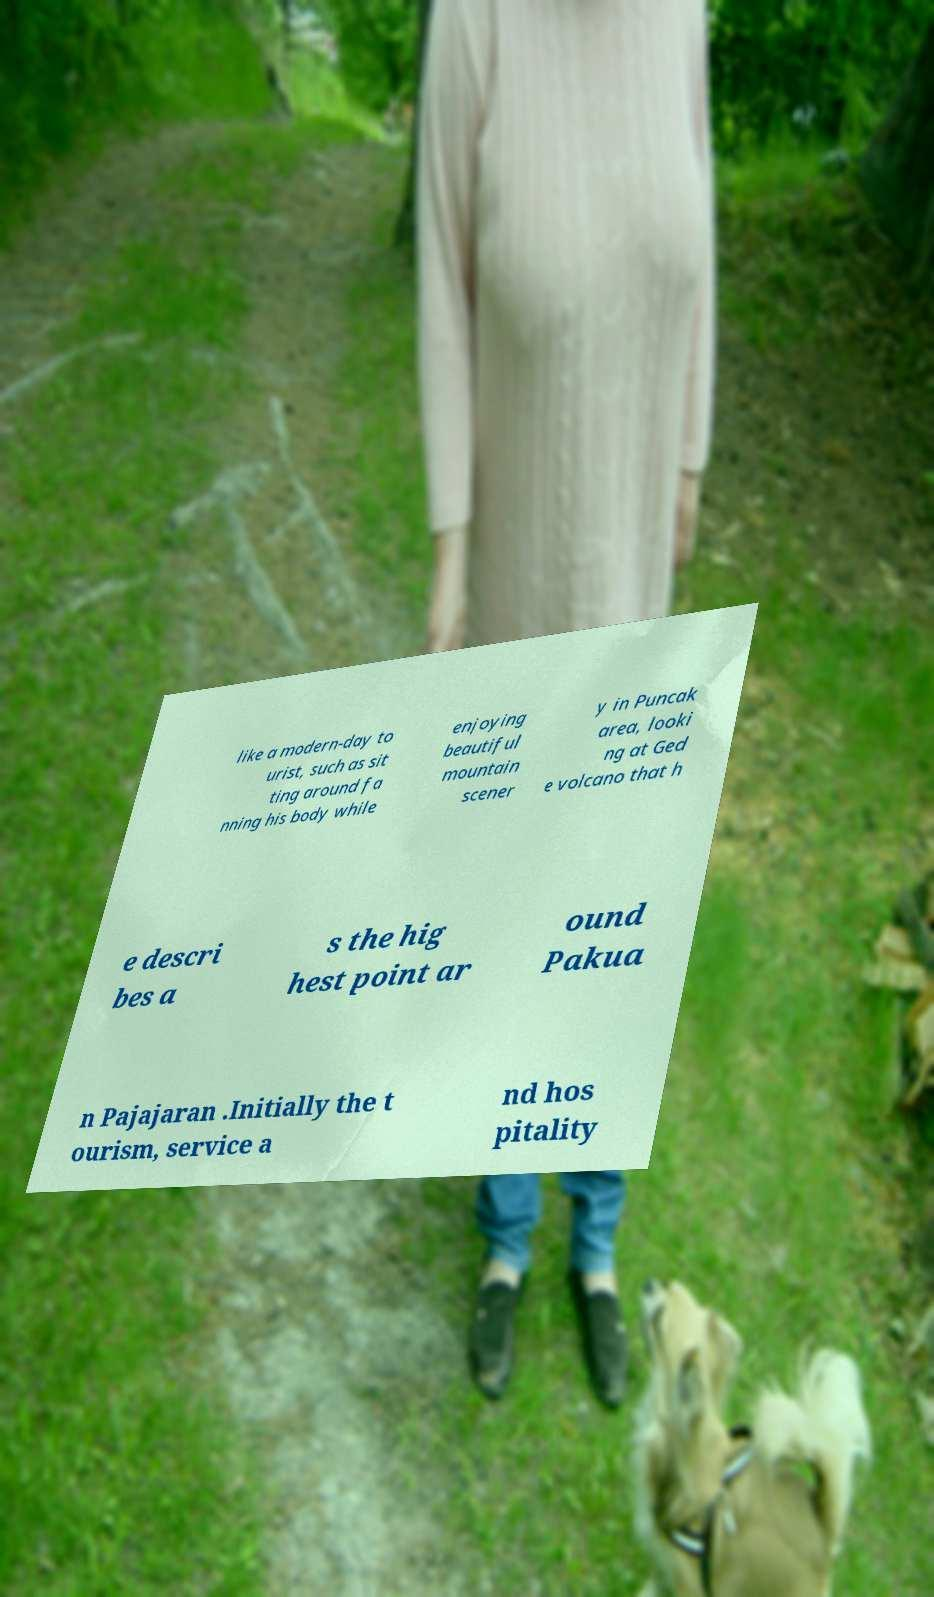For documentation purposes, I need the text within this image transcribed. Could you provide that? like a modern-day to urist, such as sit ting around fa nning his body while enjoying beautiful mountain scener y in Puncak area, looki ng at Ged e volcano that h e descri bes a s the hig hest point ar ound Pakua n Pajajaran .Initially the t ourism, service a nd hos pitality 